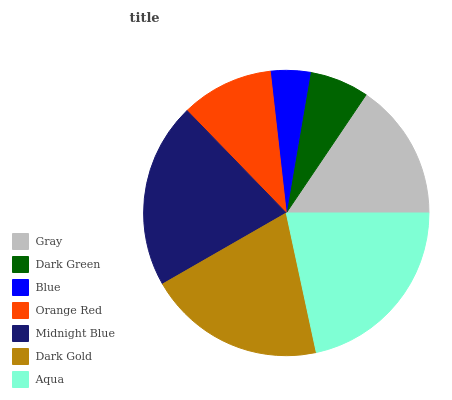Is Blue the minimum?
Answer yes or no. Yes. Is Aqua the maximum?
Answer yes or no. Yes. Is Dark Green the minimum?
Answer yes or no. No. Is Dark Green the maximum?
Answer yes or no. No. Is Gray greater than Dark Green?
Answer yes or no. Yes. Is Dark Green less than Gray?
Answer yes or no. Yes. Is Dark Green greater than Gray?
Answer yes or no. No. Is Gray less than Dark Green?
Answer yes or no. No. Is Gray the high median?
Answer yes or no. Yes. Is Gray the low median?
Answer yes or no. Yes. Is Aqua the high median?
Answer yes or no. No. Is Aqua the low median?
Answer yes or no. No. 